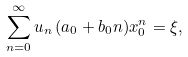<formula> <loc_0><loc_0><loc_500><loc_500>\sum _ { n = 0 } ^ { \infty } u _ { n } \, ( a _ { 0 } + b _ { 0 } n ) x _ { 0 } ^ { n } = \xi ,</formula> 